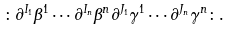<formula> <loc_0><loc_0><loc_500><loc_500>\colon \partial ^ { I _ { 1 } } \beta ^ { 1 } \cdots \partial ^ { I _ { n } } \beta ^ { n } \partial ^ { J _ { 1 } } \gamma ^ { 1 } \cdots \partial ^ { J _ { n } } \gamma ^ { n } \colon .</formula> 